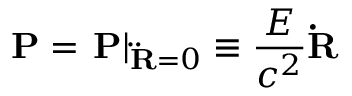Convert formula to latex. <formula><loc_0><loc_0><loc_500><loc_500>{ P } = { P } \right | _ { { \ddot { R } } = 0 } \equiv \frac { E } { c ^ { 2 } } { \dot { R } }</formula> 